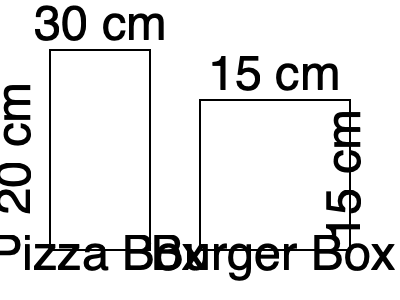As a Deliveroo rider in London, you often handle different food containers. Given a pizza box with dimensions 30 cm × 30 cm × 5 cm and a burger box with dimensions 15 cm × 15 cm × 15 cm, how many times greater is the volume of the pizza box compared to the burger box? Let's approach this step-by-step:

1. Calculate the volume of the pizza box:
   $V_{pizza} = 30 \text{ cm} \times 30 \text{ cm} \times 5 \text{ cm} = 4500 \text{ cm}^3$

2. Calculate the volume of the burger box:
   $V_{burger} = 15 \text{ cm} \times 15 \text{ cm} \times 15 \text{ cm} = 3375 \text{ cm}^3$

3. To find how many times greater the pizza box volume is, divide the pizza box volume by the burger box volume:
   $\frac{V_{pizza}}{V_{burger}} = \frac{4500 \text{ cm}^3}{3375 \text{ cm}^3} = \frac{4}{3} = 1.33333...$

4. Round to two decimal places:
   $1.33333... \approx 1.33$

Therefore, the volume of the pizza box is approximately 1.33 times greater than the volume of the burger box.
Answer: 1.33 times 